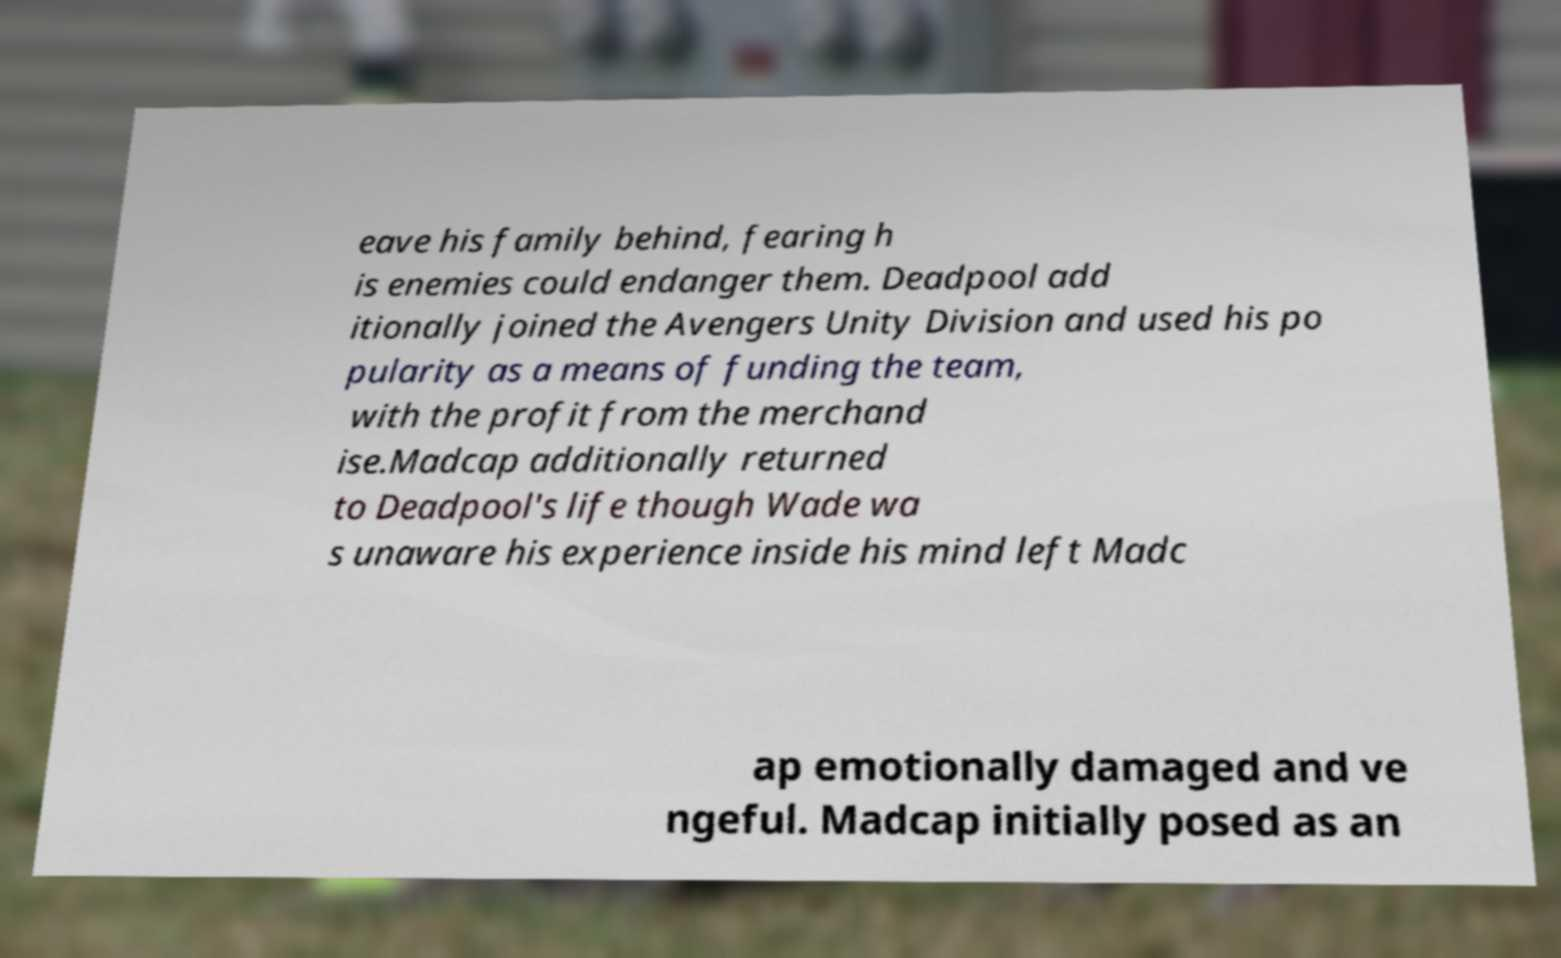Could you extract and type out the text from this image? eave his family behind, fearing h is enemies could endanger them. Deadpool add itionally joined the Avengers Unity Division and used his po pularity as a means of funding the team, with the profit from the merchand ise.Madcap additionally returned to Deadpool's life though Wade wa s unaware his experience inside his mind left Madc ap emotionally damaged and ve ngeful. Madcap initially posed as an 